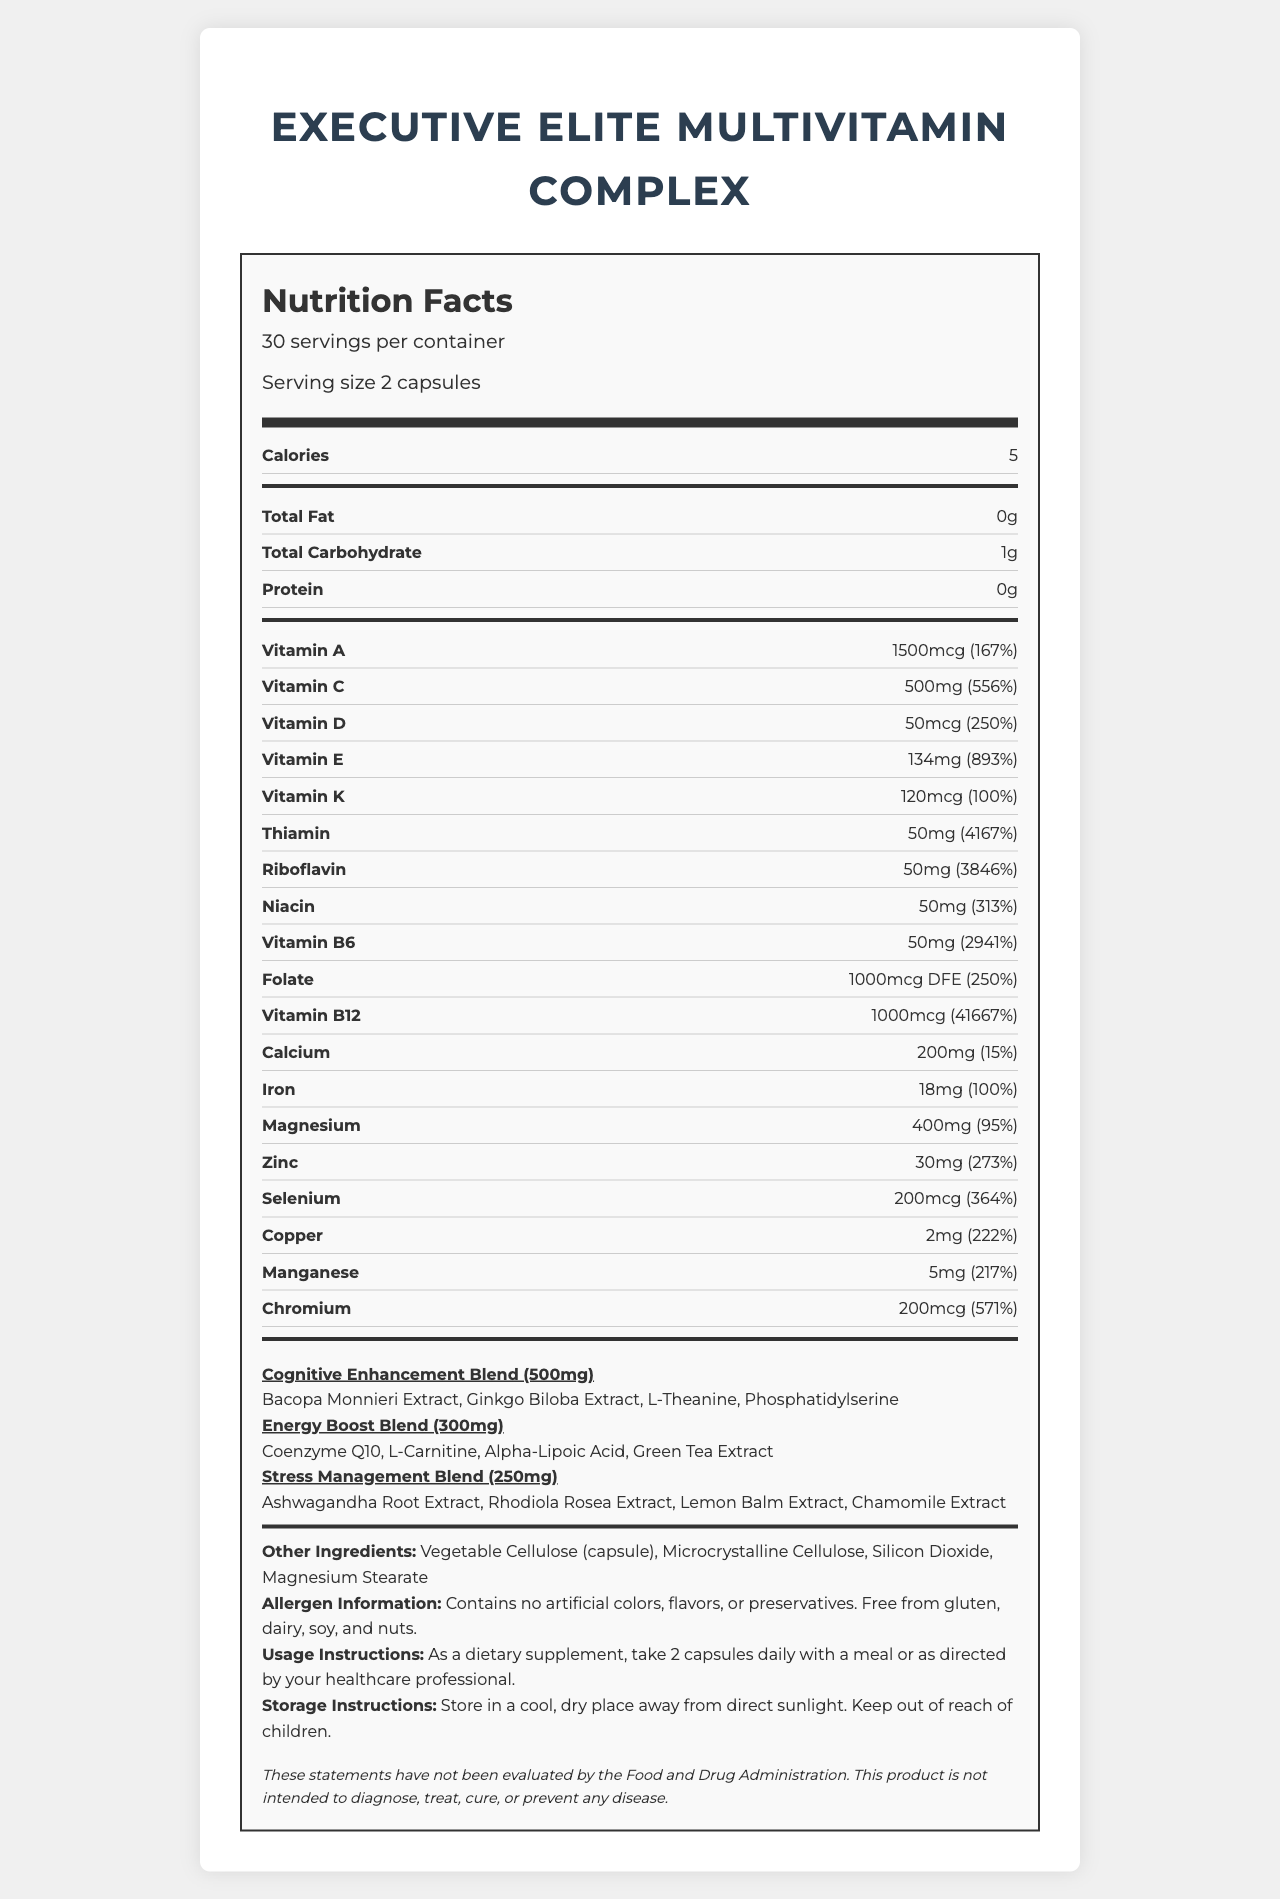what is the serving size of the Executive Elite Multivitamin Complex? The serving size is listed as "2 capsules" in the document.
Answer: 2 capsules how many servings per container are there? The document states there are 30 servings per container.
Answer: 30 how many calories are there per serving? The number of calories per serving is mentioned as 5 in the document.
Answer: 5 what is the daily value percentage of Vitamin C in this complex? The daily value percentage of Vitamin C is listed as 556%.
Answer: 556% which vitamins have a daily value percentage over 300%? The vitamins listed with daily value percentages over 300% are Vitamin C (556%), Vitamin E (893%), Thiamin (4167%), Riboflavin (3846%), Niacin (313%), Vitamin B6 (2941%), and Vitamin B12 (41667%).
Answer: Vitamin C, Vitamin E, Thiamin, Riboflavin, Niacin, Vitamin B6, Vitamin B12 which blend contains Bacopa Monnieri Extract? Bacopa Monnieri Extract is listed under the Cognitive Enhancement Blend in the ingredients section.
Answer: Cognitive Enhancement Blend which vitamin has the highest daily value percentage? A. Vitamin A B. Vitamin B12 C. Vitamin E D. Vitamin D Among the options, Vitamin B12 has the highest daily value percentage at 41667%.
Answer: B. Vitamin B12 which proprietary blend has the smallest amount in milligrams? A. Cognitive Enhancement Blend B. Energy Boost Blend C. Stress Management Blend Stress Management Blend has 250mg, which is the smallest amount compared to the other blends.
Answer: C. Stress Management Blend is this product free from gluten and dairy? The allergen information specifies that the product is free from gluten, dairy, soy, and nuts.
Answer: Yes does the document provide any information about the manufacturing process of the supplements? The document only includes information about the ingredients, nutritional values, usage instructions, storage instructions, and allergen information but does not mention the manufacturing process.
Answer: Not enough information summarize the main idea of this document. This summary covers the key information provided in the document, highlighting the purpose of the product and describing the main sections of the document in brief.
Answer: The document provides the nutritional information and ingredient details of the Executive Elite Multivitamin Complex, which is designed to support the demanding lifestyle of business leaders. It includes a breakdown of vitamins, minerals, proprietary blends, and other ingredients, as well as usage and storage instructions, allergen information, and a disclaimer. 